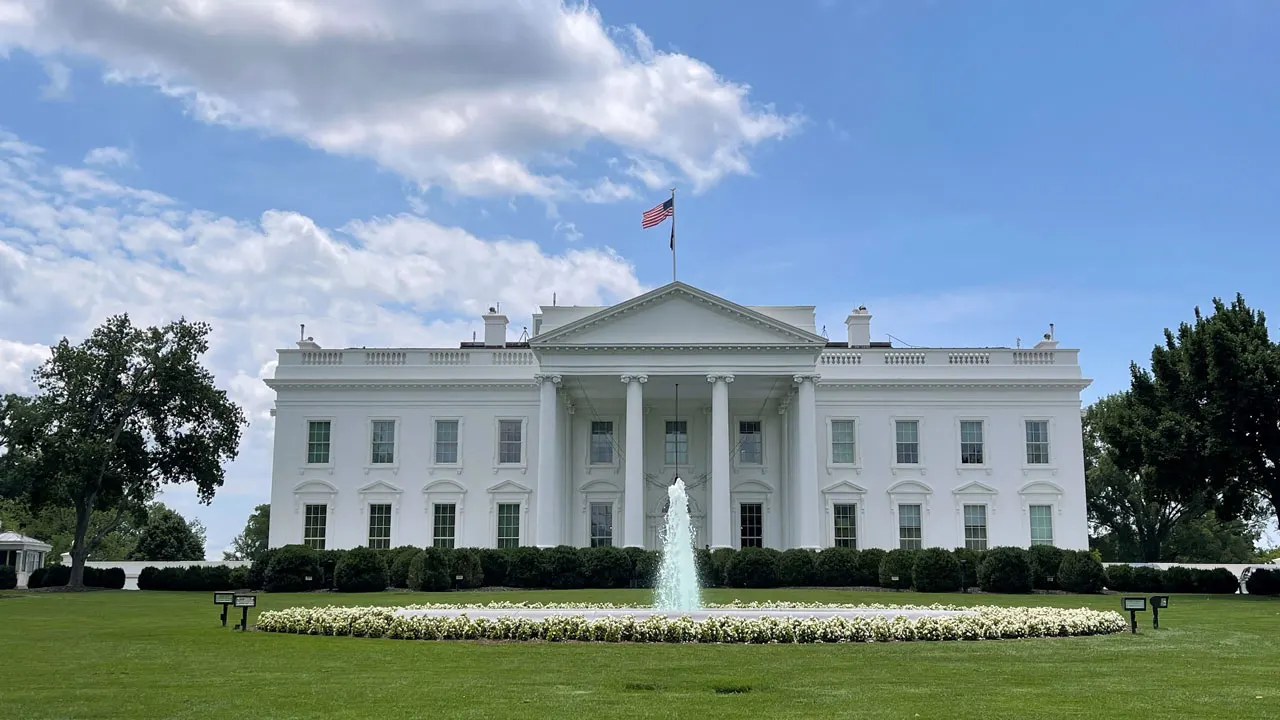Describe the architectural style of the White House. The White House is designed in the neoclassical style, characterized by its grand, symmetrical shape and the use of classical Greek and Roman architectural elements. The prominent columns at the front entrance, the triangular pediment above them, and the evenly spaced windows all contribute to its stately and enduring appearance. This design choice reflects the historical and cultural significance of the building, aligning it with the ideals of democracy and republic rooted in ancient civilizations. 